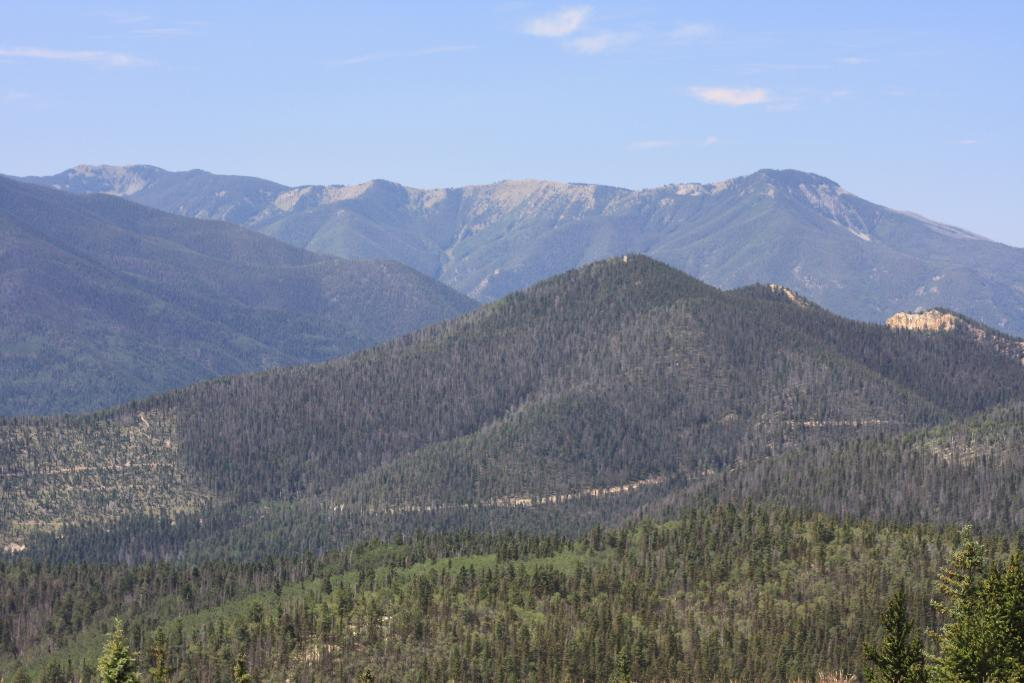What type of natural landscape is depicted in the image? The image features many mountains. What other natural elements can be seen in the image? There are trees visible in the image. What is visible in the background of the image? The sky is visible in the background of the image. What can be observed in the sky in the image? Clouds are present in the background of the image. Where is the throne located in the image? There is no throne present in the image. What type of glove is being worn by the trees in the image? There are no gloves present in the image, as trees do not wear gloves. Can you see any cornfields in the image? There are no cornfields present in the image. 